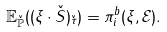<formula> <loc_0><loc_0><loc_500><loc_500>\mathbb { E } _ { \check { \mathbb { P } } } ( ( \xi \cdot \check { S } ) _ { \check { \tau } } ) = \pi ^ { b } _ { i } ( \xi , \mathcal { E } ) .</formula> 